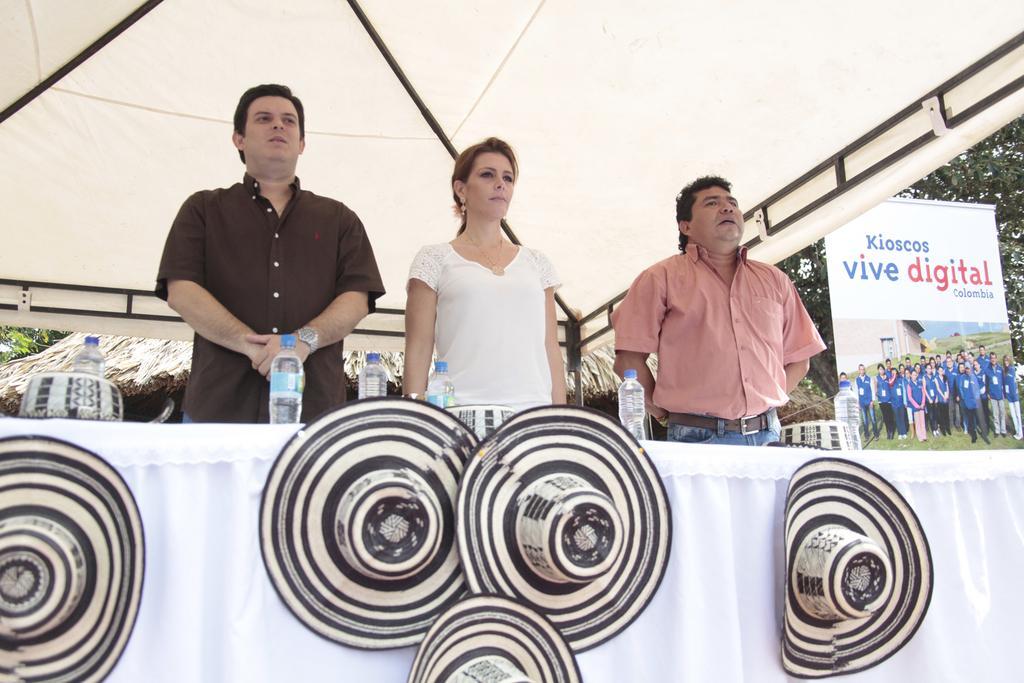Please provide a concise description of this image. In this picture we can see a few hats on a white cloth. There are bottles and a bowl on the table. We can see three people standing. There is a tent, banner, hut and a few trees in the background. 